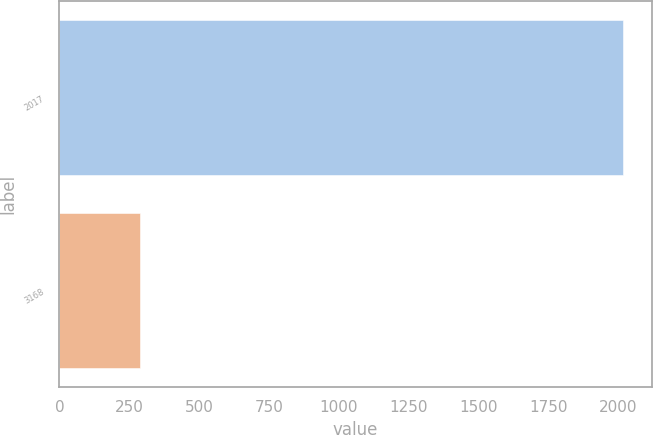Convert chart to OTSL. <chart><loc_0><loc_0><loc_500><loc_500><bar_chart><fcel>2017<fcel>3168<nl><fcel>2019<fcel>288.2<nl></chart> 